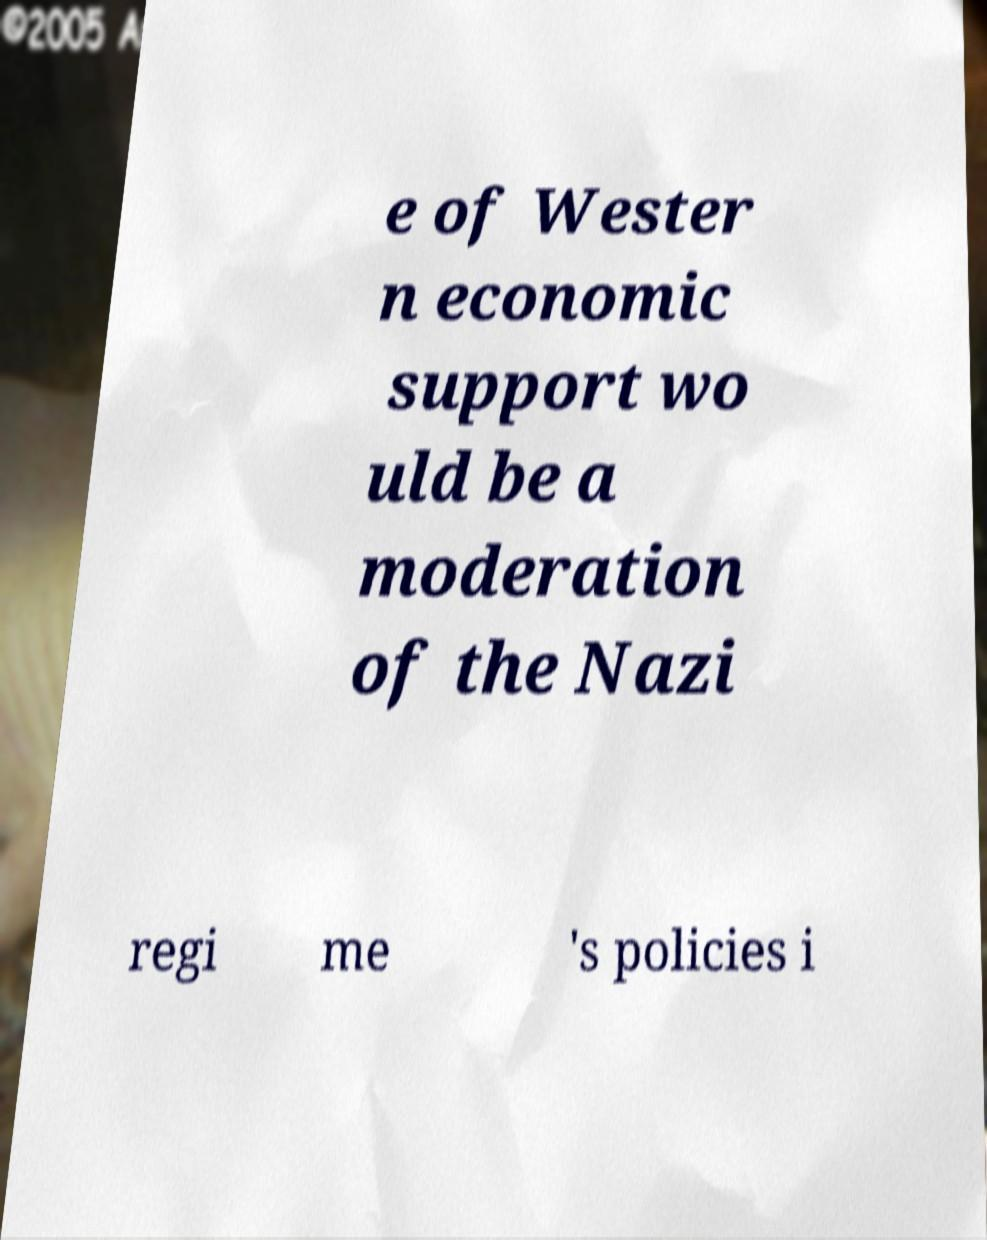Could you extract and type out the text from this image? e of Wester n economic support wo uld be a moderation of the Nazi regi me 's policies i 